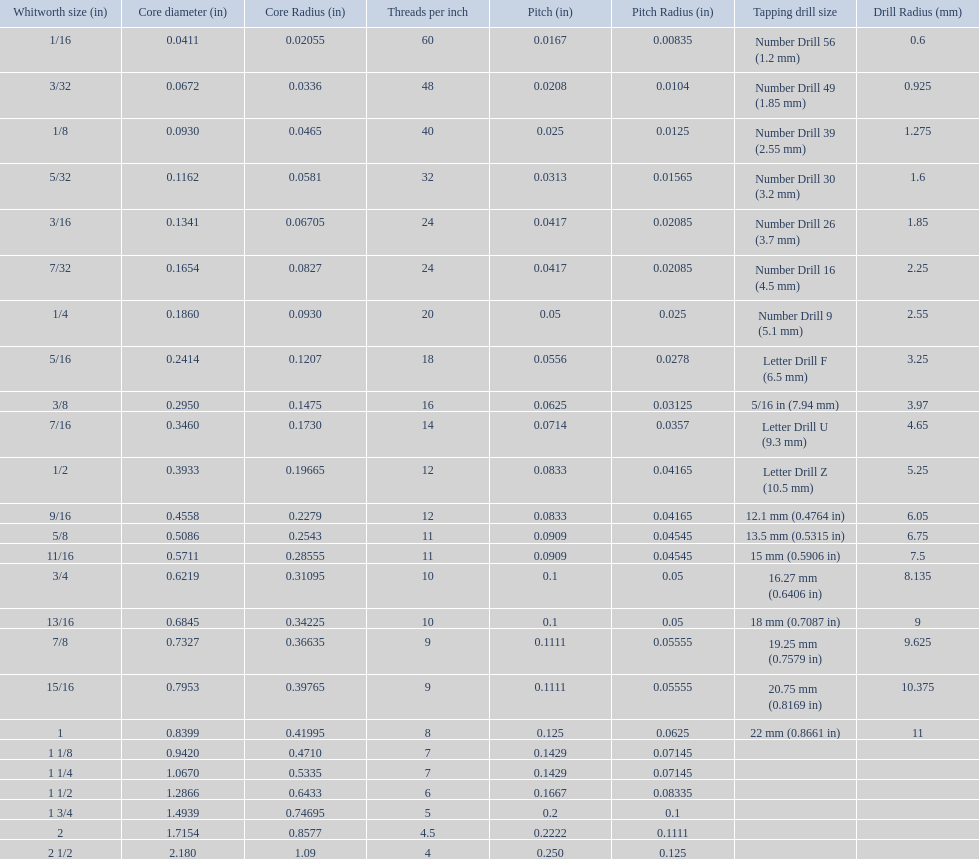What is the total of the first two core diameters? 0.1083. 